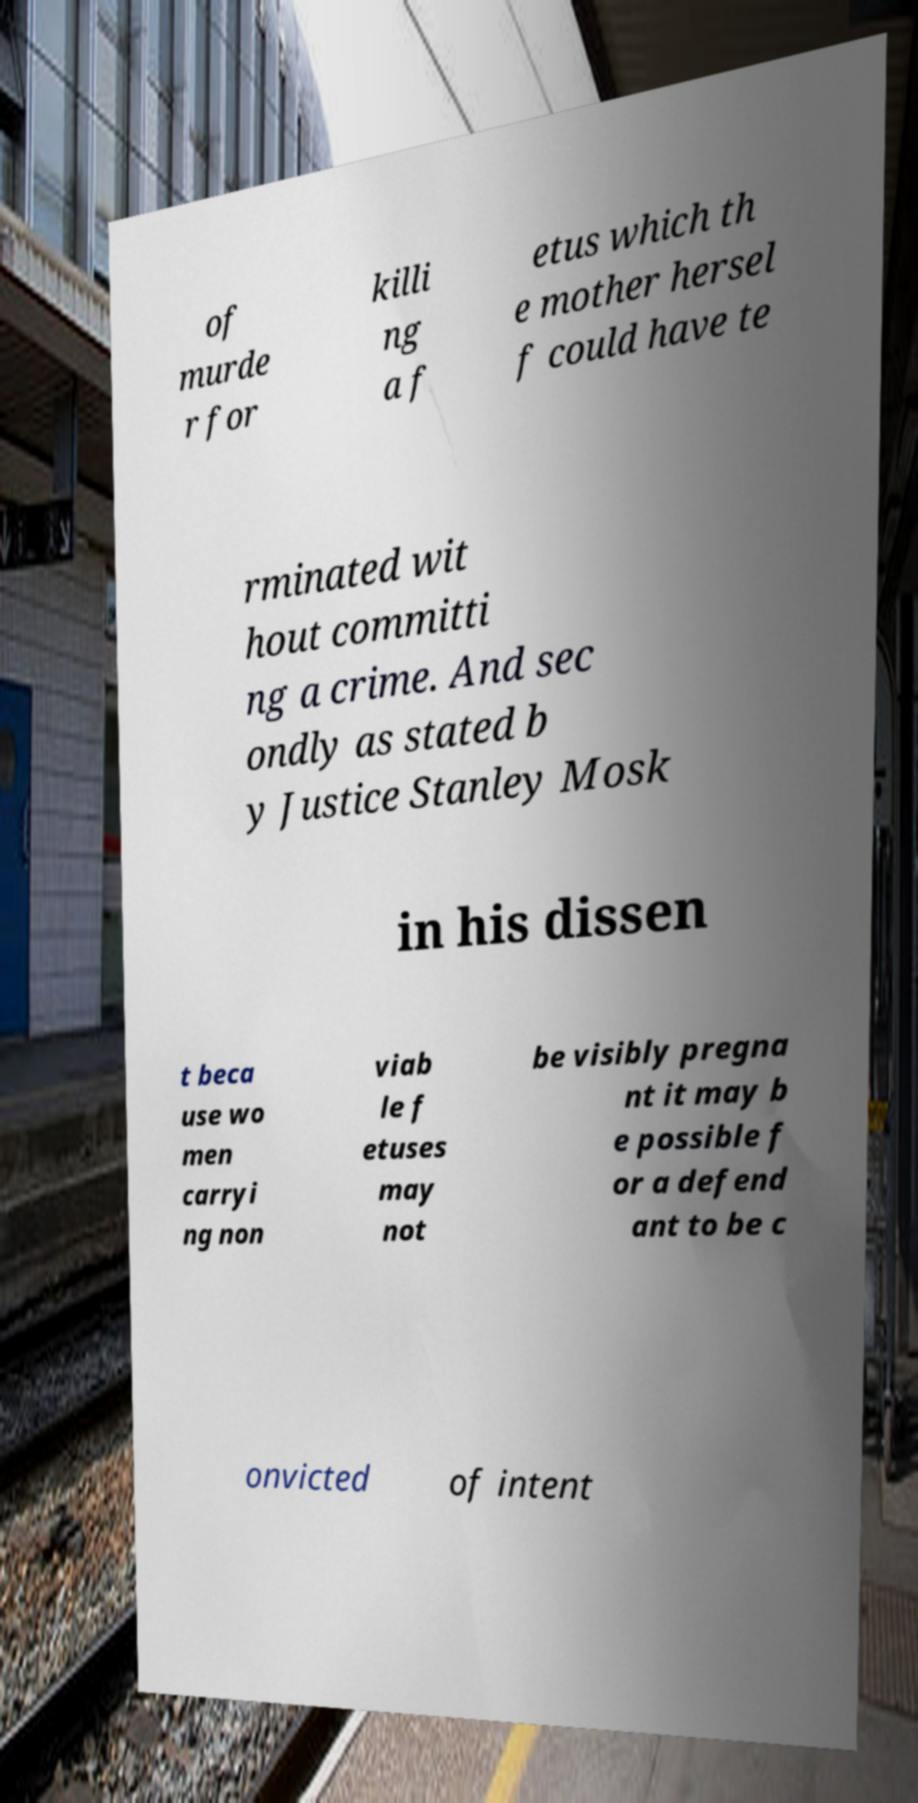Can you read and provide the text displayed in the image?This photo seems to have some interesting text. Can you extract and type it out for me? of murde r for killi ng a f etus which th e mother hersel f could have te rminated wit hout committi ng a crime. And sec ondly as stated b y Justice Stanley Mosk in his dissen t beca use wo men carryi ng non viab le f etuses may not be visibly pregna nt it may b e possible f or a defend ant to be c onvicted of intent 